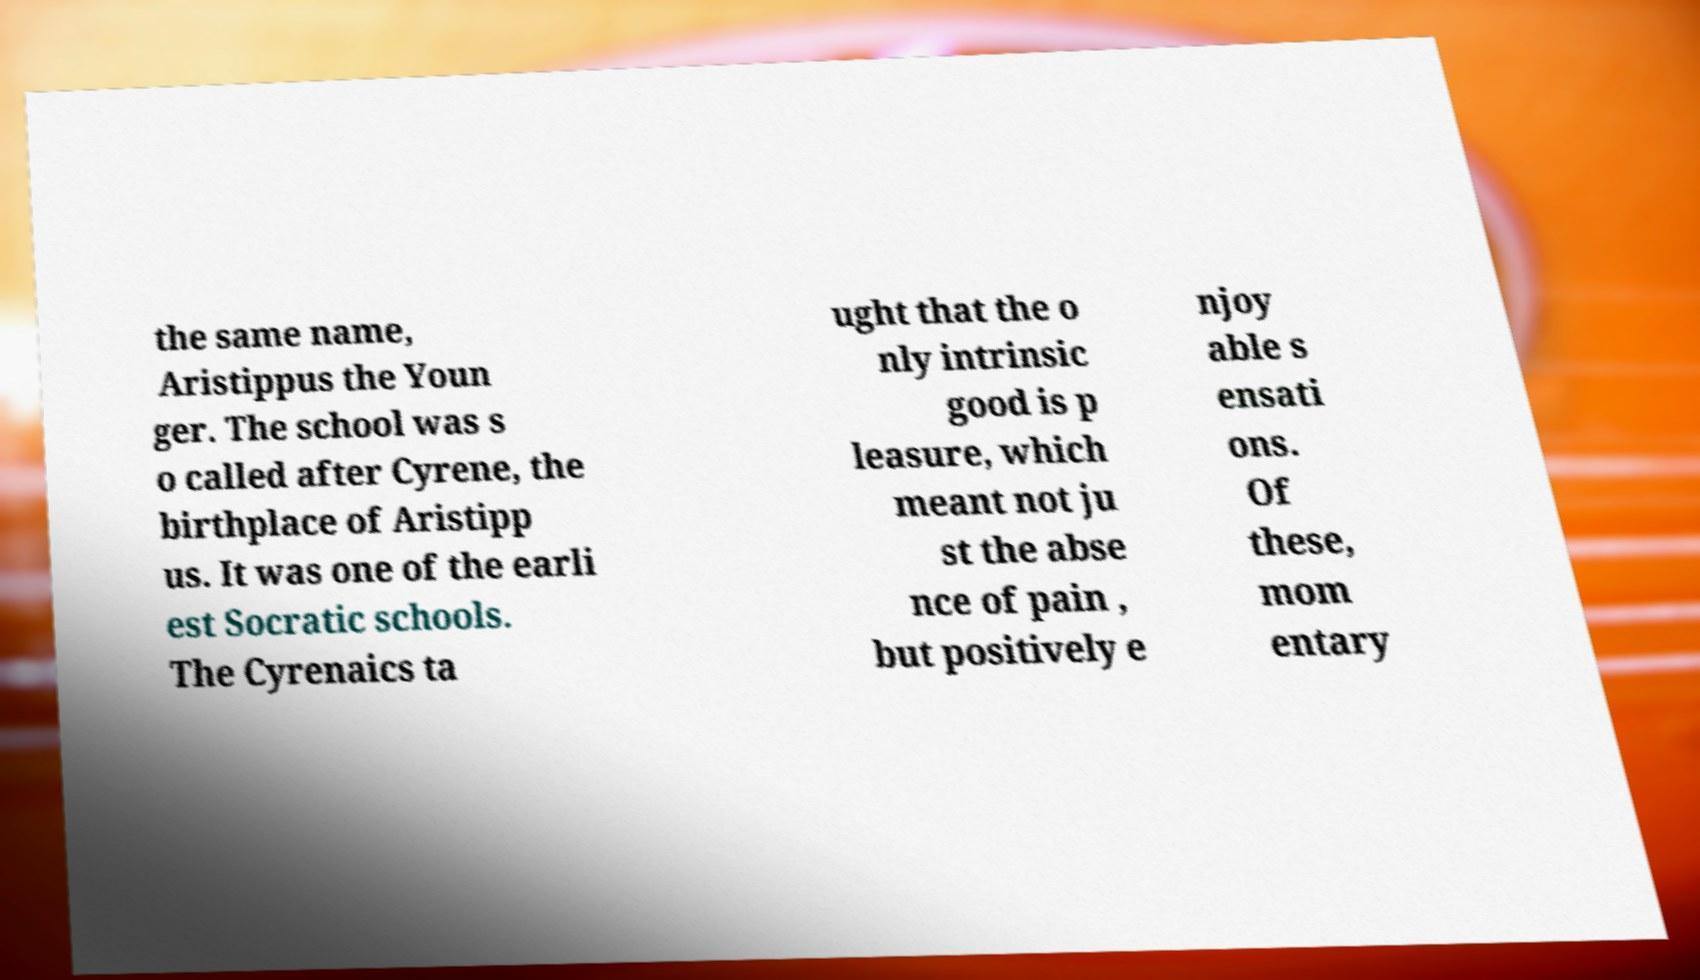There's text embedded in this image that I need extracted. Can you transcribe it verbatim? the same name, Aristippus the Youn ger. The school was s o called after Cyrene, the birthplace of Aristipp us. It was one of the earli est Socratic schools. The Cyrenaics ta ught that the o nly intrinsic good is p leasure, which meant not ju st the abse nce of pain , but positively e njoy able s ensati ons. Of these, mom entary 